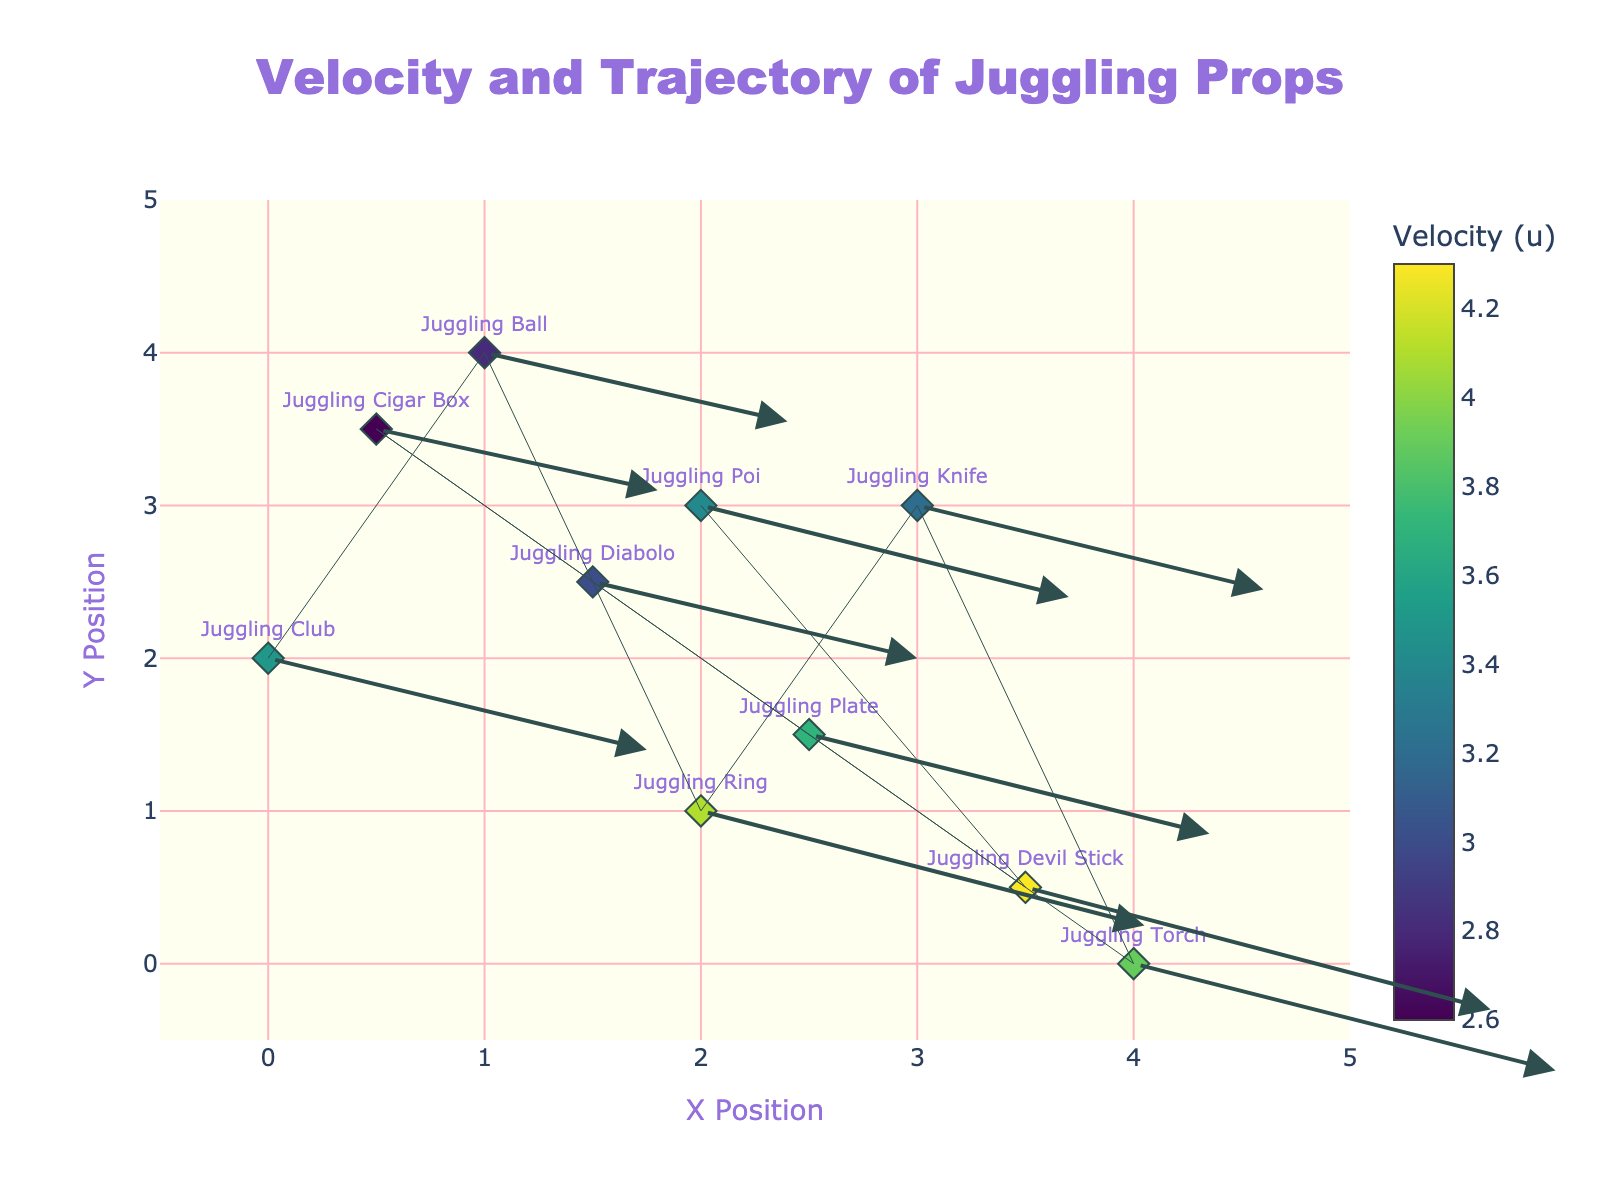What is the title of the figure? The title is displayed at the top of the figure, centered and in a larger font size. It reads 'Velocity and Trajectory of Juggling Props'.
Answer: Velocity and Trajectory of Juggling Props How many different types of juggling props are represented in the figure? Each data point in the plot represents a different juggling prop, identified by unique text labels near the markers. By counting these labels, we find there are 10 different types of juggling props.
Answer: 10 Which juggling prop has the highest initial y-position? The initial y-positions are displayed on the y-axis. By looking at the positions of the markers, the 'Juggling Ball' has the highest initial y-position at y=4.
Answer: Juggling Ball What is the average u-component of the velocity for all the props? The u-component values are given in the data. To find the average, sum all the u-values (3.5 + 2.8 + 4.1 + 3.2 + 3.9 + 3.0 + 3.7 + 2.6 + 4.3 + 3.4) and divide by the number of props (10). This gives (3.5 + 2.8 + 4.1 + 3.2 + 3.9 + 3.0 + 3.7 + 2.6 + 4.3 + 3.4) / 10 = 34.5 / 10 = 3.45.
Answer: 3.45 Which prop's velocity is represented by the longest arrow? The length of the arrow represents the resultant velocity, calculated by the vector magnitude sqrt(u^2 + v^2). Comparing all props, the 'Juggling Devil Stick' has the largest magnitude sqrt(4.3^2 + (-1.6)^2) = sqrt(18.49 + 2.56) = sqrt(21.05) ≈ 4.59.
Answer: Juggling Devil Stick Which juggling prop exhibits the smallest x-component of velocity? The x-component (u) of velocity is indicated by the color of the marker and value labels. The 'Juggling Cigar Box' has the smallest x-component, u = 2.6.
Answer: Juggling Cigar Box Which two props have the same initial y position and what is that position? By looking at the y-values in the visual plot, the 'Juggling Knife' and 'Juggling Poi' both have an initial y position of 3.
Answer: Juggling Knife and Juggling Poi, y=3 What is the range of x positions covered by the props? The x positions vary from a minimum value of 0 (Juggling Club) to a maximum value of 4 (Juggling Torch). Therefore, the range is from 0 to 4.
Answer: 0 to 4 Which prop has the steepest downward trajectory? The steepest downward trajectory is represented by the largest negative v-component of velocity. 'Juggling Devil Stick' has the most negative v-component, v = -1.6.
Answer: Juggling Devil Stick 